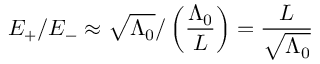<formula> <loc_0><loc_0><loc_500><loc_500>E _ { + } / E _ { - } \approx \sqrt { \Lambda _ { 0 } } / \left ( \frac { \Lambda _ { 0 } } { L } \right ) = \frac { L } { \sqrt { \Lambda _ { 0 } } }</formula> 